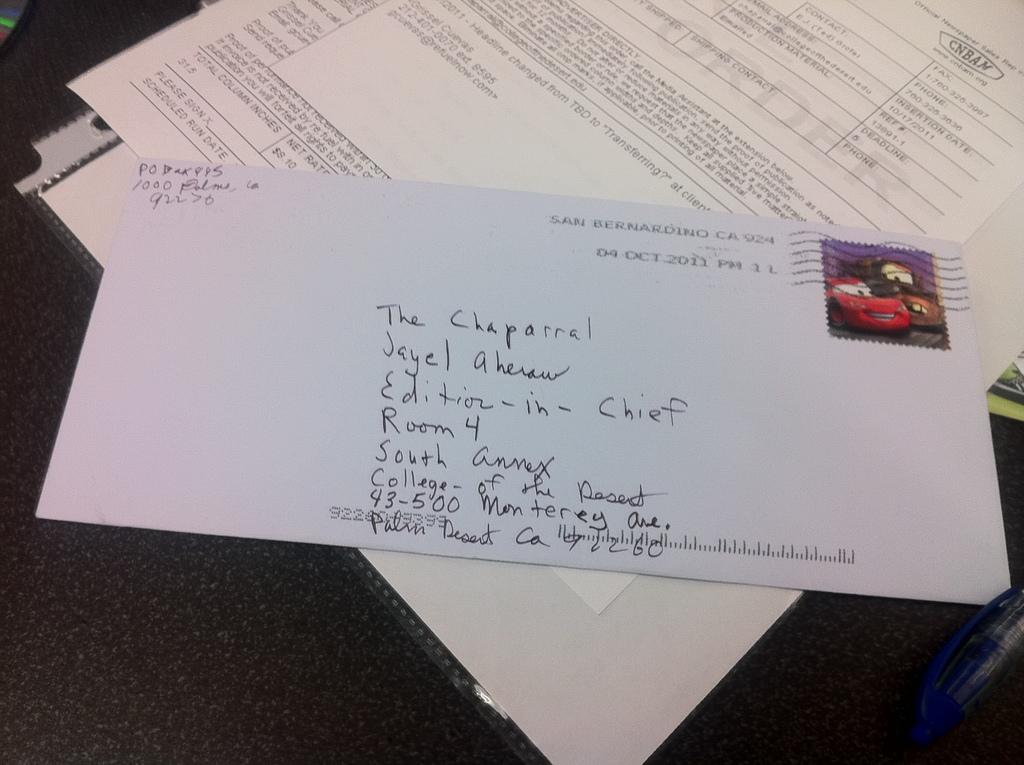<image>
Describe the image concisely. A hand addressed envelope was mailed to The Chaparral. 